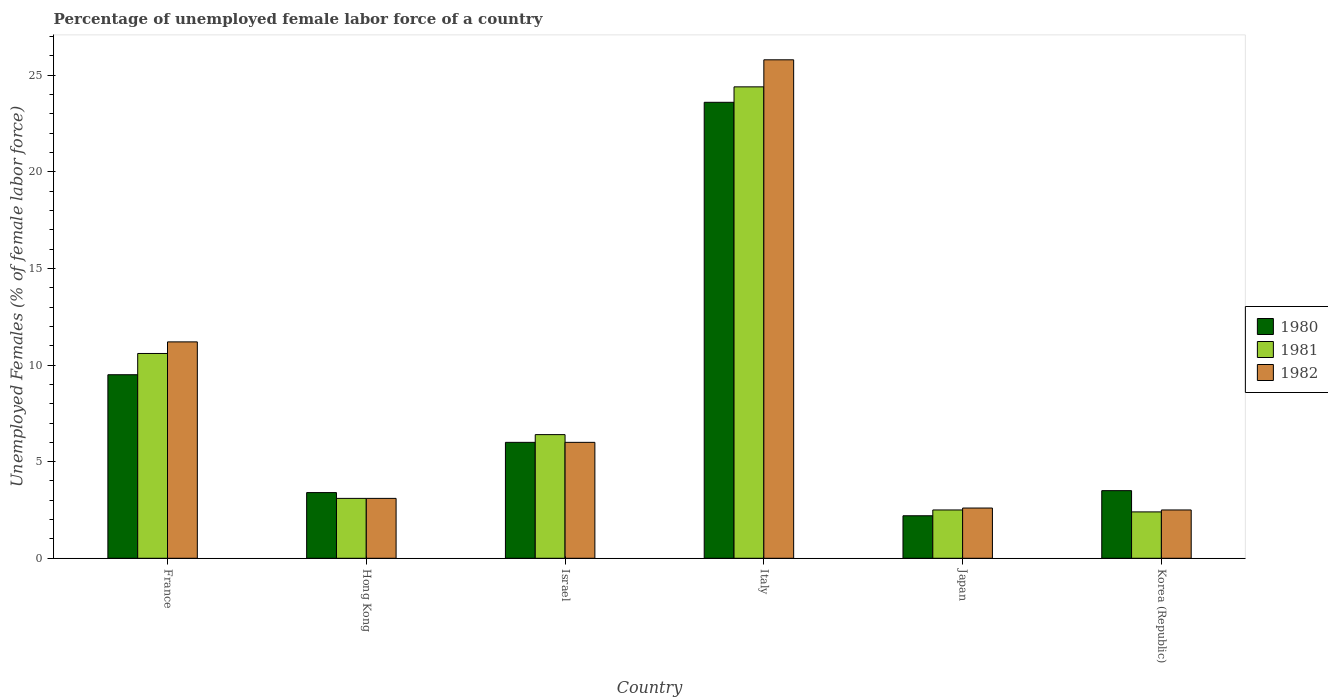How many different coloured bars are there?
Provide a short and direct response. 3. How many groups of bars are there?
Keep it short and to the point. 6. Are the number of bars per tick equal to the number of legend labels?
Your response must be concise. Yes. Are the number of bars on each tick of the X-axis equal?
Make the answer very short. Yes. How many bars are there on the 2nd tick from the left?
Ensure brevity in your answer.  3. How many bars are there on the 4th tick from the right?
Give a very brief answer. 3. What is the label of the 4th group of bars from the left?
Your response must be concise. Italy. What is the percentage of unemployed female labor force in 1981 in Israel?
Ensure brevity in your answer.  6.4. Across all countries, what is the maximum percentage of unemployed female labor force in 1981?
Make the answer very short. 24.4. Across all countries, what is the minimum percentage of unemployed female labor force in 1980?
Provide a short and direct response. 2.2. In which country was the percentage of unemployed female labor force in 1982 maximum?
Provide a short and direct response. Italy. What is the total percentage of unemployed female labor force in 1982 in the graph?
Offer a very short reply. 51.2. What is the difference between the percentage of unemployed female labor force in 1980 in France and that in Korea (Republic)?
Give a very brief answer. 6. What is the difference between the percentage of unemployed female labor force in 1981 in Hong Kong and the percentage of unemployed female labor force in 1980 in Japan?
Offer a terse response. 0.9. What is the average percentage of unemployed female labor force in 1980 per country?
Offer a terse response. 8.03. What is the difference between the percentage of unemployed female labor force of/in 1982 and percentage of unemployed female labor force of/in 1980 in Hong Kong?
Your answer should be compact. -0.3. What is the ratio of the percentage of unemployed female labor force in 1980 in Hong Kong to that in Japan?
Your answer should be very brief. 1.55. What is the difference between the highest and the second highest percentage of unemployed female labor force in 1982?
Your answer should be compact. 14.6. What is the difference between the highest and the lowest percentage of unemployed female labor force in 1982?
Provide a succinct answer. 23.3. In how many countries, is the percentage of unemployed female labor force in 1982 greater than the average percentage of unemployed female labor force in 1982 taken over all countries?
Your response must be concise. 2. Is the sum of the percentage of unemployed female labor force in 1980 in Hong Kong and Japan greater than the maximum percentage of unemployed female labor force in 1981 across all countries?
Your answer should be very brief. No. Is it the case that in every country, the sum of the percentage of unemployed female labor force in 1981 and percentage of unemployed female labor force in 1982 is greater than the percentage of unemployed female labor force in 1980?
Your answer should be compact. Yes. How many countries are there in the graph?
Provide a succinct answer. 6. Are the values on the major ticks of Y-axis written in scientific E-notation?
Offer a very short reply. No. Does the graph contain any zero values?
Offer a terse response. No. How are the legend labels stacked?
Offer a terse response. Vertical. What is the title of the graph?
Provide a succinct answer. Percentage of unemployed female labor force of a country. Does "2010" appear as one of the legend labels in the graph?
Give a very brief answer. No. What is the label or title of the X-axis?
Make the answer very short. Country. What is the label or title of the Y-axis?
Provide a short and direct response. Unemployed Females (% of female labor force). What is the Unemployed Females (% of female labor force) in 1981 in France?
Your answer should be compact. 10.6. What is the Unemployed Females (% of female labor force) in 1982 in France?
Provide a short and direct response. 11.2. What is the Unemployed Females (% of female labor force) of 1980 in Hong Kong?
Ensure brevity in your answer.  3.4. What is the Unemployed Females (% of female labor force) in 1981 in Hong Kong?
Your response must be concise. 3.1. What is the Unemployed Females (% of female labor force) in 1982 in Hong Kong?
Keep it short and to the point. 3.1. What is the Unemployed Females (% of female labor force) in 1981 in Israel?
Make the answer very short. 6.4. What is the Unemployed Females (% of female labor force) in 1982 in Israel?
Your response must be concise. 6. What is the Unemployed Females (% of female labor force) of 1980 in Italy?
Ensure brevity in your answer.  23.6. What is the Unemployed Females (% of female labor force) of 1981 in Italy?
Keep it short and to the point. 24.4. What is the Unemployed Females (% of female labor force) of 1982 in Italy?
Ensure brevity in your answer.  25.8. What is the Unemployed Females (% of female labor force) of 1980 in Japan?
Your answer should be very brief. 2.2. What is the Unemployed Females (% of female labor force) in 1981 in Japan?
Make the answer very short. 2.5. What is the Unemployed Females (% of female labor force) in 1982 in Japan?
Your answer should be very brief. 2.6. What is the Unemployed Females (% of female labor force) of 1981 in Korea (Republic)?
Give a very brief answer. 2.4. What is the Unemployed Females (% of female labor force) in 1982 in Korea (Republic)?
Make the answer very short. 2.5. Across all countries, what is the maximum Unemployed Females (% of female labor force) in 1980?
Give a very brief answer. 23.6. Across all countries, what is the maximum Unemployed Females (% of female labor force) of 1981?
Provide a succinct answer. 24.4. Across all countries, what is the maximum Unemployed Females (% of female labor force) of 1982?
Keep it short and to the point. 25.8. Across all countries, what is the minimum Unemployed Females (% of female labor force) in 1980?
Offer a very short reply. 2.2. Across all countries, what is the minimum Unemployed Females (% of female labor force) of 1981?
Make the answer very short. 2.4. What is the total Unemployed Females (% of female labor force) of 1980 in the graph?
Provide a succinct answer. 48.2. What is the total Unemployed Females (% of female labor force) in 1981 in the graph?
Keep it short and to the point. 49.4. What is the total Unemployed Females (% of female labor force) of 1982 in the graph?
Give a very brief answer. 51.2. What is the difference between the Unemployed Females (% of female labor force) in 1981 in France and that in Hong Kong?
Your answer should be compact. 7.5. What is the difference between the Unemployed Females (% of female labor force) in 1980 in France and that in Israel?
Make the answer very short. 3.5. What is the difference between the Unemployed Females (% of female labor force) in 1980 in France and that in Italy?
Offer a very short reply. -14.1. What is the difference between the Unemployed Females (% of female labor force) of 1982 in France and that in Italy?
Your response must be concise. -14.6. What is the difference between the Unemployed Females (% of female labor force) of 1980 in France and that in Japan?
Ensure brevity in your answer.  7.3. What is the difference between the Unemployed Females (% of female labor force) in 1981 in France and that in Japan?
Your response must be concise. 8.1. What is the difference between the Unemployed Females (% of female labor force) in 1980 in France and that in Korea (Republic)?
Give a very brief answer. 6. What is the difference between the Unemployed Females (% of female labor force) of 1982 in France and that in Korea (Republic)?
Provide a short and direct response. 8.7. What is the difference between the Unemployed Females (% of female labor force) in 1980 in Hong Kong and that in Israel?
Offer a terse response. -2.6. What is the difference between the Unemployed Females (% of female labor force) of 1982 in Hong Kong and that in Israel?
Keep it short and to the point. -2.9. What is the difference between the Unemployed Females (% of female labor force) in 1980 in Hong Kong and that in Italy?
Provide a succinct answer. -20.2. What is the difference between the Unemployed Females (% of female labor force) of 1981 in Hong Kong and that in Italy?
Ensure brevity in your answer.  -21.3. What is the difference between the Unemployed Females (% of female labor force) of 1982 in Hong Kong and that in Italy?
Ensure brevity in your answer.  -22.7. What is the difference between the Unemployed Females (% of female labor force) of 1981 in Hong Kong and that in Japan?
Ensure brevity in your answer.  0.6. What is the difference between the Unemployed Females (% of female labor force) in 1981 in Hong Kong and that in Korea (Republic)?
Make the answer very short. 0.7. What is the difference between the Unemployed Females (% of female labor force) of 1980 in Israel and that in Italy?
Your answer should be compact. -17.6. What is the difference between the Unemployed Females (% of female labor force) in 1982 in Israel and that in Italy?
Provide a succinct answer. -19.8. What is the difference between the Unemployed Females (% of female labor force) in 1980 in Israel and that in Japan?
Keep it short and to the point. 3.8. What is the difference between the Unemployed Females (% of female labor force) in 1981 in Israel and that in Japan?
Ensure brevity in your answer.  3.9. What is the difference between the Unemployed Females (% of female labor force) of 1980 in Israel and that in Korea (Republic)?
Ensure brevity in your answer.  2.5. What is the difference between the Unemployed Females (% of female labor force) in 1982 in Israel and that in Korea (Republic)?
Make the answer very short. 3.5. What is the difference between the Unemployed Females (% of female labor force) of 1980 in Italy and that in Japan?
Give a very brief answer. 21.4. What is the difference between the Unemployed Females (% of female labor force) of 1981 in Italy and that in Japan?
Make the answer very short. 21.9. What is the difference between the Unemployed Females (% of female labor force) of 1982 in Italy and that in Japan?
Give a very brief answer. 23.2. What is the difference between the Unemployed Females (% of female labor force) of 1980 in Italy and that in Korea (Republic)?
Your answer should be compact. 20.1. What is the difference between the Unemployed Females (% of female labor force) of 1981 in Italy and that in Korea (Republic)?
Your answer should be very brief. 22. What is the difference between the Unemployed Females (% of female labor force) in 1982 in Italy and that in Korea (Republic)?
Your answer should be very brief. 23.3. What is the difference between the Unemployed Females (% of female labor force) of 1980 in Japan and that in Korea (Republic)?
Keep it short and to the point. -1.3. What is the difference between the Unemployed Females (% of female labor force) in 1982 in Japan and that in Korea (Republic)?
Your answer should be compact. 0.1. What is the difference between the Unemployed Females (% of female labor force) of 1980 in France and the Unemployed Females (% of female labor force) of 1982 in Hong Kong?
Keep it short and to the point. 6.4. What is the difference between the Unemployed Females (% of female labor force) in 1980 in France and the Unemployed Females (% of female labor force) in 1981 in Israel?
Your answer should be compact. 3.1. What is the difference between the Unemployed Females (% of female labor force) in 1980 in France and the Unemployed Females (% of female labor force) in 1981 in Italy?
Ensure brevity in your answer.  -14.9. What is the difference between the Unemployed Females (% of female labor force) in 1980 in France and the Unemployed Females (% of female labor force) in 1982 in Italy?
Provide a succinct answer. -16.3. What is the difference between the Unemployed Females (% of female labor force) in 1981 in France and the Unemployed Females (% of female labor force) in 1982 in Italy?
Provide a succinct answer. -15.2. What is the difference between the Unemployed Females (% of female labor force) in 1980 in France and the Unemployed Females (% of female labor force) in 1981 in Japan?
Your answer should be very brief. 7. What is the difference between the Unemployed Females (% of female labor force) of 1980 in France and the Unemployed Females (% of female labor force) of 1982 in Japan?
Offer a terse response. 6.9. What is the difference between the Unemployed Females (% of female labor force) in 1981 in France and the Unemployed Females (% of female labor force) in 1982 in Japan?
Your response must be concise. 8. What is the difference between the Unemployed Females (% of female labor force) in 1980 in France and the Unemployed Females (% of female labor force) in 1981 in Korea (Republic)?
Your response must be concise. 7.1. What is the difference between the Unemployed Females (% of female labor force) in 1981 in France and the Unemployed Females (% of female labor force) in 1982 in Korea (Republic)?
Provide a succinct answer. 8.1. What is the difference between the Unemployed Females (% of female labor force) of 1980 in Hong Kong and the Unemployed Females (% of female labor force) of 1981 in Israel?
Provide a succinct answer. -3. What is the difference between the Unemployed Females (% of female labor force) in 1980 in Hong Kong and the Unemployed Females (% of female labor force) in 1982 in Italy?
Provide a succinct answer. -22.4. What is the difference between the Unemployed Females (% of female labor force) in 1981 in Hong Kong and the Unemployed Females (% of female labor force) in 1982 in Italy?
Ensure brevity in your answer.  -22.7. What is the difference between the Unemployed Females (% of female labor force) of 1981 in Hong Kong and the Unemployed Females (% of female labor force) of 1982 in Japan?
Ensure brevity in your answer.  0.5. What is the difference between the Unemployed Females (% of female labor force) of 1980 in Hong Kong and the Unemployed Females (% of female labor force) of 1981 in Korea (Republic)?
Keep it short and to the point. 1. What is the difference between the Unemployed Females (% of female labor force) of 1980 in Hong Kong and the Unemployed Females (% of female labor force) of 1982 in Korea (Republic)?
Ensure brevity in your answer.  0.9. What is the difference between the Unemployed Females (% of female labor force) in 1981 in Hong Kong and the Unemployed Females (% of female labor force) in 1982 in Korea (Republic)?
Give a very brief answer. 0.6. What is the difference between the Unemployed Females (% of female labor force) in 1980 in Israel and the Unemployed Females (% of female labor force) in 1981 in Italy?
Provide a succinct answer. -18.4. What is the difference between the Unemployed Females (% of female labor force) in 1980 in Israel and the Unemployed Females (% of female labor force) in 1982 in Italy?
Your answer should be compact. -19.8. What is the difference between the Unemployed Females (% of female labor force) of 1981 in Israel and the Unemployed Females (% of female labor force) of 1982 in Italy?
Provide a short and direct response. -19.4. What is the difference between the Unemployed Females (% of female labor force) in 1981 in Israel and the Unemployed Females (% of female labor force) in 1982 in Japan?
Your answer should be very brief. 3.8. What is the difference between the Unemployed Females (% of female labor force) of 1980 in Israel and the Unemployed Females (% of female labor force) of 1982 in Korea (Republic)?
Give a very brief answer. 3.5. What is the difference between the Unemployed Females (% of female labor force) of 1981 in Israel and the Unemployed Females (% of female labor force) of 1982 in Korea (Republic)?
Offer a very short reply. 3.9. What is the difference between the Unemployed Females (% of female labor force) in 1980 in Italy and the Unemployed Females (% of female labor force) in 1981 in Japan?
Make the answer very short. 21.1. What is the difference between the Unemployed Females (% of female labor force) of 1981 in Italy and the Unemployed Females (% of female labor force) of 1982 in Japan?
Give a very brief answer. 21.8. What is the difference between the Unemployed Females (% of female labor force) of 1980 in Italy and the Unemployed Females (% of female labor force) of 1981 in Korea (Republic)?
Provide a short and direct response. 21.2. What is the difference between the Unemployed Females (% of female labor force) in 1980 in Italy and the Unemployed Females (% of female labor force) in 1982 in Korea (Republic)?
Provide a succinct answer. 21.1. What is the difference between the Unemployed Females (% of female labor force) in 1981 in Italy and the Unemployed Females (% of female labor force) in 1982 in Korea (Republic)?
Offer a terse response. 21.9. What is the difference between the Unemployed Females (% of female labor force) in 1980 in Japan and the Unemployed Females (% of female labor force) in 1982 in Korea (Republic)?
Offer a very short reply. -0.3. What is the average Unemployed Females (% of female labor force) in 1980 per country?
Your response must be concise. 8.03. What is the average Unemployed Females (% of female labor force) of 1981 per country?
Provide a short and direct response. 8.23. What is the average Unemployed Females (% of female labor force) of 1982 per country?
Your answer should be compact. 8.53. What is the difference between the Unemployed Females (% of female labor force) in 1980 and Unemployed Females (% of female labor force) in 1981 in France?
Provide a succinct answer. -1.1. What is the difference between the Unemployed Females (% of female labor force) in 1980 and Unemployed Females (% of female labor force) in 1982 in France?
Provide a succinct answer. -1.7. What is the difference between the Unemployed Females (% of female labor force) in 1980 and Unemployed Females (% of female labor force) in 1982 in Hong Kong?
Your response must be concise. 0.3. What is the difference between the Unemployed Females (% of female labor force) of 1980 and Unemployed Females (% of female labor force) of 1981 in Italy?
Ensure brevity in your answer.  -0.8. What is the difference between the Unemployed Females (% of female labor force) of 1980 and Unemployed Females (% of female labor force) of 1982 in Italy?
Keep it short and to the point. -2.2. What is the difference between the Unemployed Females (% of female labor force) of 1981 and Unemployed Females (% of female labor force) of 1982 in Italy?
Offer a terse response. -1.4. What is the difference between the Unemployed Females (% of female labor force) in 1980 and Unemployed Females (% of female labor force) in 1981 in Japan?
Provide a succinct answer. -0.3. What is the difference between the Unemployed Females (% of female labor force) of 1981 and Unemployed Females (% of female labor force) of 1982 in Japan?
Give a very brief answer. -0.1. What is the difference between the Unemployed Females (% of female labor force) of 1981 and Unemployed Females (% of female labor force) of 1982 in Korea (Republic)?
Make the answer very short. -0.1. What is the ratio of the Unemployed Females (% of female labor force) in 1980 in France to that in Hong Kong?
Make the answer very short. 2.79. What is the ratio of the Unemployed Females (% of female labor force) in 1981 in France to that in Hong Kong?
Give a very brief answer. 3.42. What is the ratio of the Unemployed Females (% of female labor force) in 1982 in France to that in Hong Kong?
Offer a terse response. 3.61. What is the ratio of the Unemployed Females (% of female labor force) of 1980 in France to that in Israel?
Offer a very short reply. 1.58. What is the ratio of the Unemployed Females (% of female labor force) of 1981 in France to that in Israel?
Offer a very short reply. 1.66. What is the ratio of the Unemployed Females (% of female labor force) of 1982 in France to that in Israel?
Offer a very short reply. 1.87. What is the ratio of the Unemployed Females (% of female labor force) of 1980 in France to that in Italy?
Give a very brief answer. 0.4. What is the ratio of the Unemployed Females (% of female labor force) of 1981 in France to that in Italy?
Your answer should be very brief. 0.43. What is the ratio of the Unemployed Females (% of female labor force) in 1982 in France to that in Italy?
Make the answer very short. 0.43. What is the ratio of the Unemployed Females (% of female labor force) in 1980 in France to that in Japan?
Give a very brief answer. 4.32. What is the ratio of the Unemployed Females (% of female labor force) in 1981 in France to that in Japan?
Provide a short and direct response. 4.24. What is the ratio of the Unemployed Females (% of female labor force) of 1982 in France to that in Japan?
Ensure brevity in your answer.  4.31. What is the ratio of the Unemployed Females (% of female labor force) in 1980 in France to that in Korea (Republic)?
Your answer should be very brief. 2.71. What is the ratio of the Unemployed Females (% of female labor force) of 1981 in France to that in Korea (Republic)?
Provide a short and direct response. 4.42. What is the ratio of the Unemployed Females (% of female labor force) in 1982 in France to that in Korea (Republic)?
Your response must be concise. 4.48. What is the ratio of the Unemployed Females (% of female labor force) of 1980 in Hong Kong to that in Israel?
Provide a short and direct response. 0.57. What is the ratio of the Unemployed Females (% of female labor force) of 1981 in Hong Kong to that in Israel?
Offer a terse response. 0.48. What is the ratio of the Unemployed Females (% of female labor force) of 1982 in Hong Kong to that in Israel?
Give a very brief answer. 0.52. What is the ratio of the Unemployed Females (% of female labor force) of 1980 in Hong Kong to that in Italy?
Provide a succinct answer. 0.14. What is the ratio of the Unemployed Females (% of female labor force) in 1981 in Hong Kong to that in Italy?
Offer a terse response. 0.13. What is the ratio of the Unemployed Females (% of female labor force) in 1982 in Hong Kong to that in Italy?
Give a very brief answer. 0.12. What is the ratio of the Unemployed Females (% of female labor force) of 1980 in Hong Kong to that in Japan?
Your response must be concise. 1.55. What is the ratio of the Unemployed Females (% of female labor force) of 1981 in Hong Kong to that in Japan?
Give a very brief answer. 1.24. What is the ratio of the Unemployed Females (% of female labor force) in 1982 in Hong Kong to that in Japan?
Provide a succinct answer. 1.19. What is the ratio of the Unemployed Females (% of female labor force) in 1980 in Hong Kong to that in Korea (Republic)?
Your response must be concise. 0.97. What is the ratio of the Unemployed Females (% of female labor force) of 1981 in Hong Kong to that in Korea (Republic)?
Keep it short and to the point. 1.29. What is the ratio of the Unemployed Females (% of female labor force) of 1982 in Hong Kong to that in Korea (Republic)?
Offer a very short reply. 1.24. What is the ratio of the Unemployed Females (% of female labor force) of 1980 in Israel to that in Italy?
Keep it short and to the point. 0.25. What is the ratio of the Unemployed Females (% of female labor force) of 1981 in Israel to that in Italy?
Provide a short and direct response. 0.26. What is the ratio of the Unemployed Females (% of female labor force) in 1982 in Israel to that in Italy?
Provide a short and direct response. 0.23. What is the ratio of the Unemployed Females (% of female labor force) in 1980 in Israel to that in Japan?
Offer a very short reply. 2.73. What is the ratio of the Unemployed Females (% of female labor force) of 1981 in Israel to that in Japan?
Offer a very short reply. 2.56. What is the ratio of the Unemployed Females (% of female labor force) in 1982 in Israel to that in Japan?
Your answer should be very brief. 2.31. What is the ratio of the Unemployed Females (% of female labor force) in 1980 in Israel to that in Korea (Republic)?
Your answer should be compact. 1.71. What is the ratio of the Unemployed Females (% of female labor force) in 1981 in Israel to that in Korea (Republic)?
Keep it short and to the point. 2.67. What is the ratio of the Unemployed Females (% of female labor force) in 1980 in Italy to that in Japan?
Make the answer very short. 10.73. What is the ratio of the Unemployed Females (% of female labor force) in 1981 in Italy to that in Japan?
Your answer should be compact. 9.76. What is the ratio of the Unemployed Females (% of female labor force) in 1982 in Italy to that in Japan?
Offer a very short reply. 9.92. What is the ratio of the Unemployed Females (% of female labor force) of 1980 in Italy to that in Korea (Republic)?
Provide a short and direct response. 6.74. What is the ratio of the Unemployed Females (% of female labor force) in 1981 in Italy to that in Korea (Republic)?
Your answer should be very brief. 10.17. What is the ratio of the Unemployed Females (% of female labor force) in 1982 in Italy to that in Korea (Republic)?
Your response must be concise. 10.32. What is the ratio of the Unemployed Females (% of female labor force) of 1980 in Japan to that in Korea (Republic)?
Give a very brief answer. 0.63. What is the ratio of the Unemployed Females (% of female labor force) of 1981 in Japan to that in Korea (Republic)?
Offer a very short reply. 1.04. What is the difference between the highest and the second highest Unemployed Females (% of female labor force) of 1980?
Offer a very short reply. 14.1. What is the difference between the highest and the second highest Unemployed Females (% of female labor force) of 1981?
Ensure brevity in your answer.  13.8. What is the difference between the highest and the second highest Unemployed Females (% of female labor force) in 1982?
Give a very brief answer. 14.6. What is the difference between the highest and the lowest Unemployed Females (% of female labor force) in 1980?
Offer a terse response. 21.4. What is the difference between the highest and the lowest Unemployed Females (% of female labor force) of 1982?
Keep it short and to the point. 23.3. 